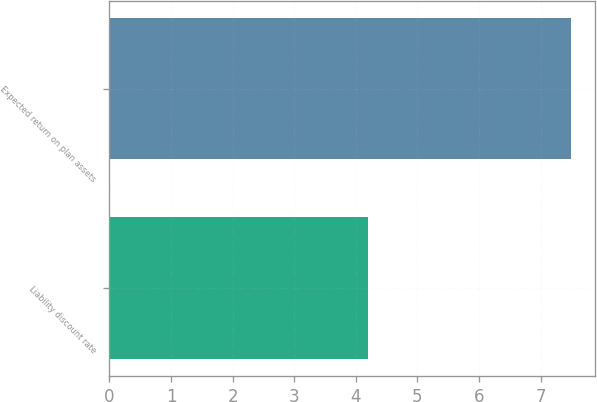<chart> <loc_0><loc_0><loc_500><loc_500><bar_chart><fcel>Liability discount rate<fcel>Expected return on plan assets<nl><fcel>4.2<fcel>7.5<nl></chart> 